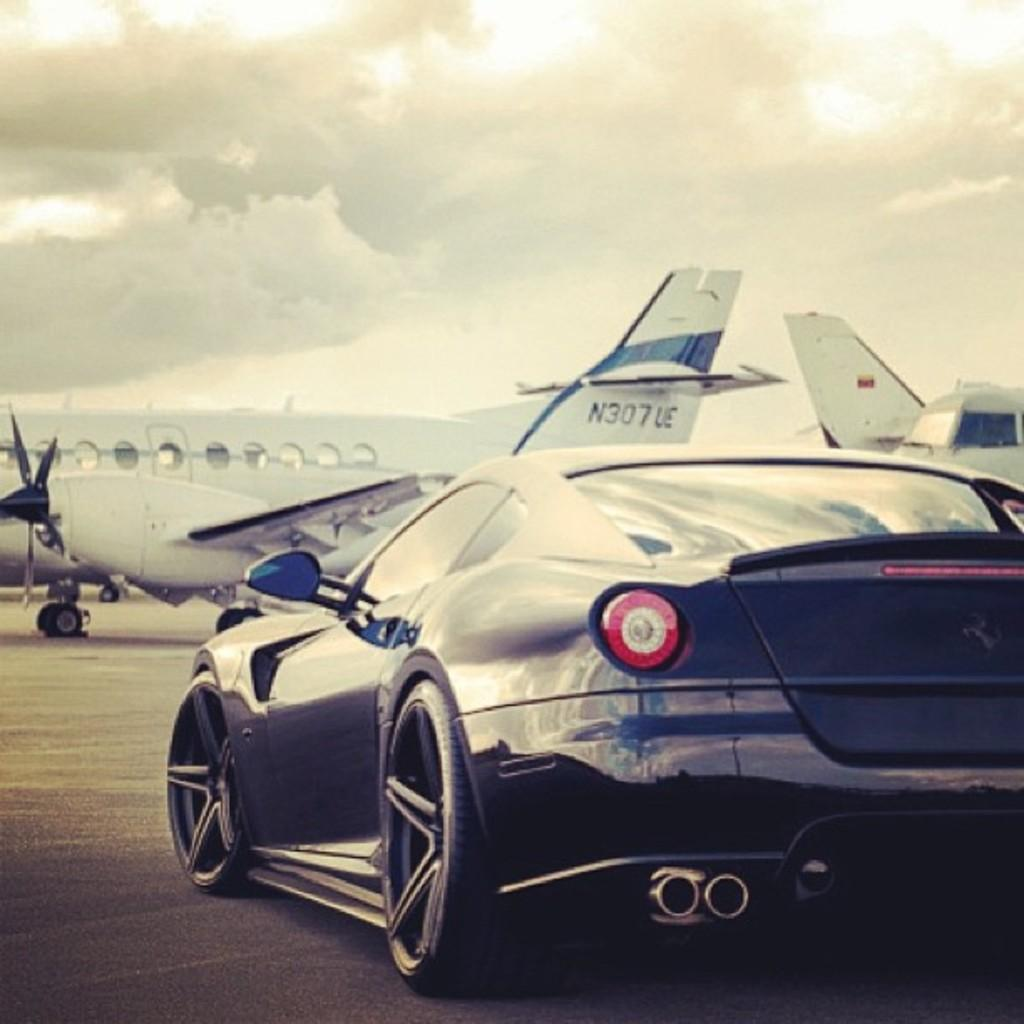<image>
Summarize the visual content of the image. A small twin propeller plane with N307UE on its tail gets ready to take off. 